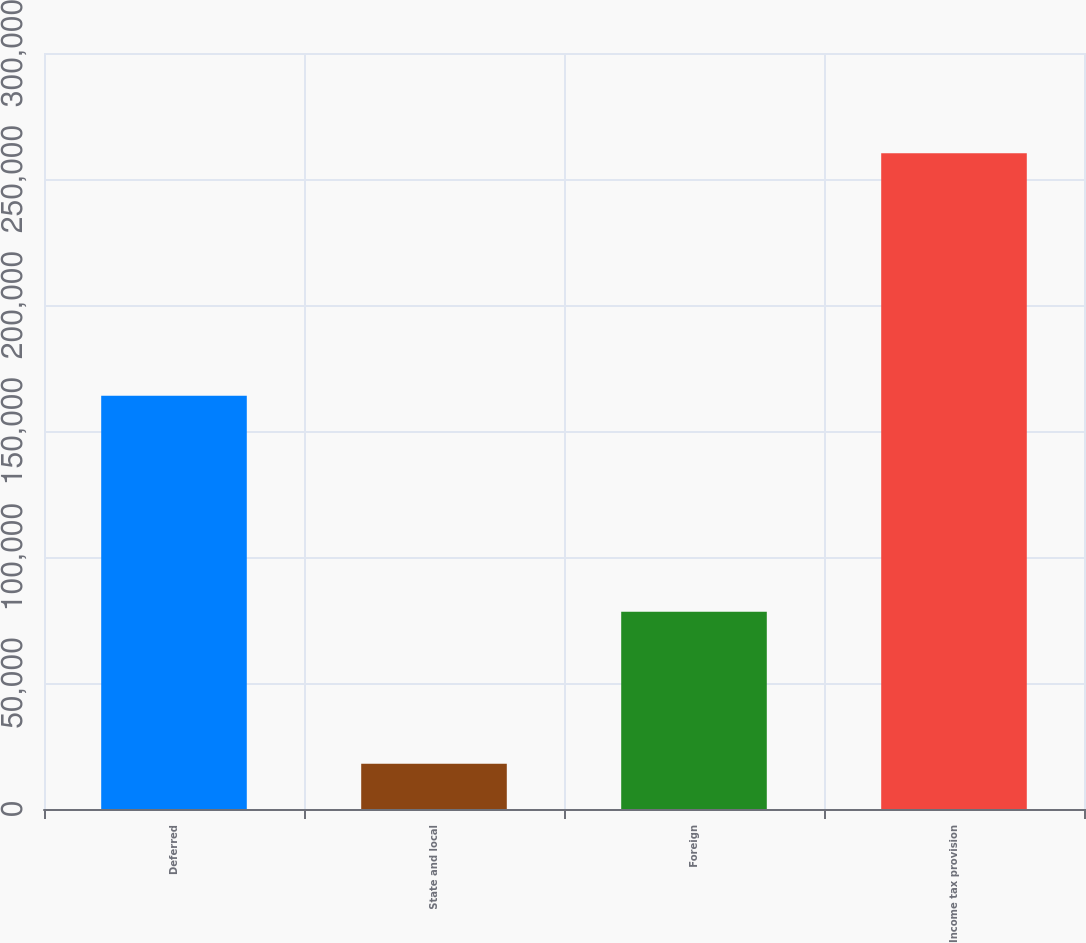Convert chart. <chart><loc_0><loc_0><loc_500><loc_500><bar_chart><fcel>Deferred<fcel>State and local<fcel>Foreign<fcel>Income tax provision<nl><fcel>163944<fcel>18000<fcel>78257<fcel>260201<nl></chart> 